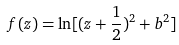Convert formula to latex. <formula><loc_0><loc_0><loc_500><loc_500>f ( z ) = \ln [ ( z + \frac { 1 } { 2 } ) ^ { 2 } + b ^ { 2 } ]</formula> 